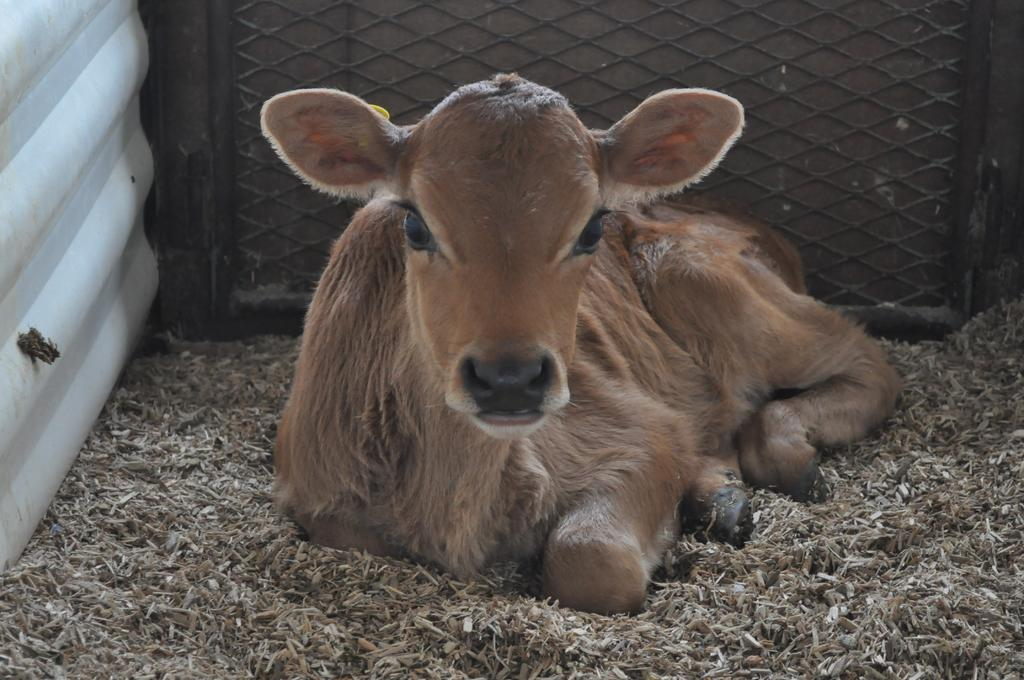What type of animal is in the picture? There is an animal in the picture, but the specific type cannot be determined from the provided facts. What is the animal doing in the image? The animal is sitting on the ground. What can be seen in the background of the image? There is a fence and other objects visible in the background of the image. What type of comb is the animal using to brush its teeth in the image? There is no comb or toothpaste present in the image; the animal is sitting on the ground. 